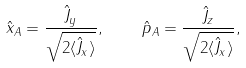Convert formula to latex. <formula><loc_0><loc_0><loc_500><loc_500>\hat { x } _ { A } = \frac { \hat { J } _ { y } } { \sqrt { 2 \langle \hat { J } _ { x } \rangle } } , \quad \hat { p } _ { A } = \frac { \hat { J } _ { z } } { \sqrt { 2 \langle \hat { J } _ { x } \rangle } } ,</formula> 